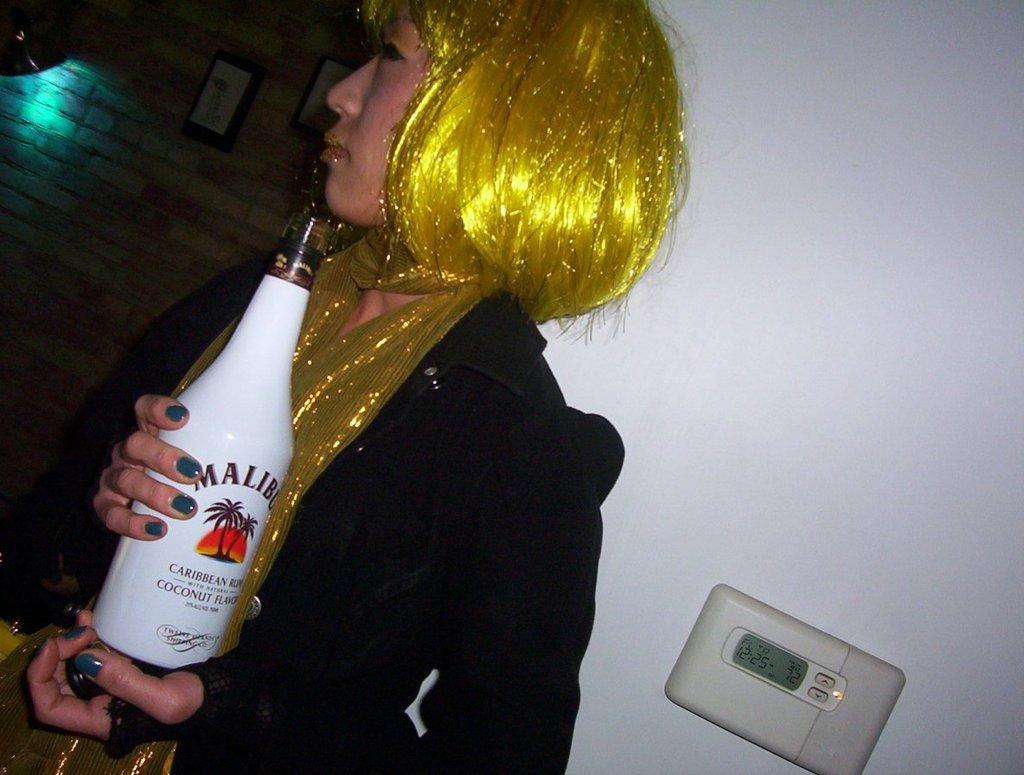Please provide a concise description of this image. In the image we can see a woman wearing clothes and holding a bottle in her hand, this is a wall and a device. 